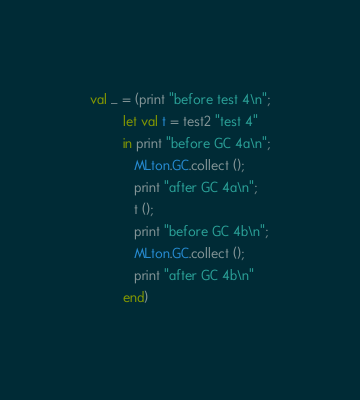Convert code to text. <code><loc_0><loc_0><loc_500><loc_500><_SML_>
val _ = (print "before test 4\n";
         let val t = test2 "test 4"
         in print "before GC 4a\n";
            MLton.GC.collect ();
            print "after GC 4a\n";
            t ();
            print "before GC 4b\n";
            MLton.GC.collect ();
            print "after GC 4b\n"
         end)
</code> 